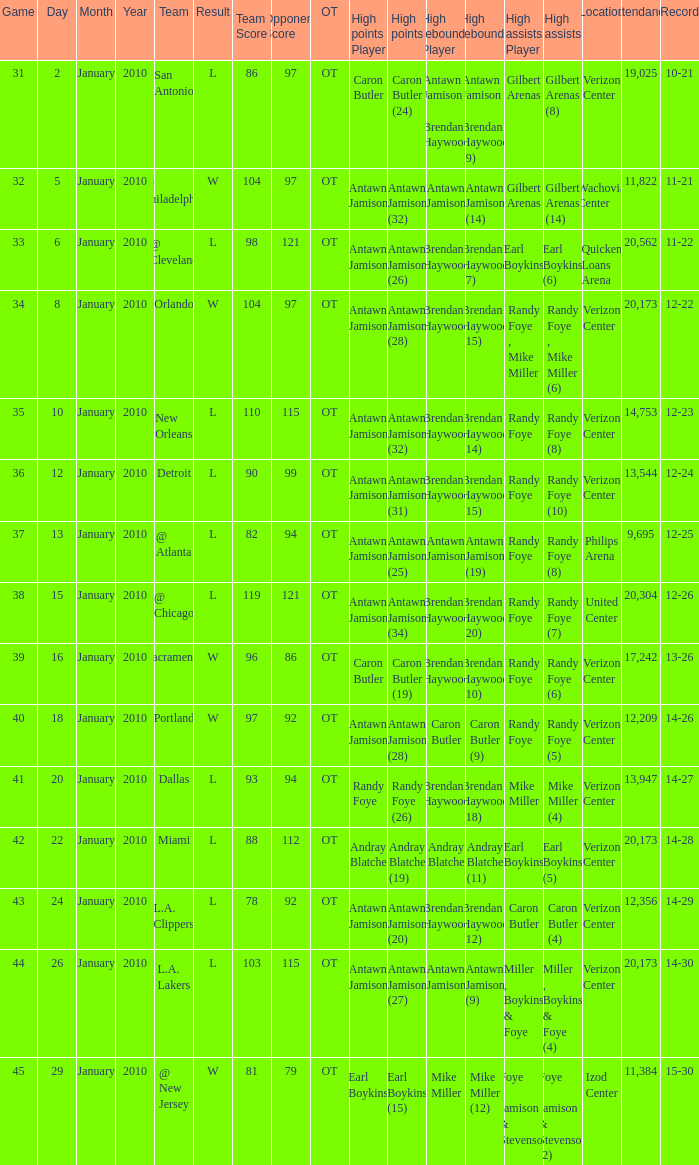Who had the highest points on January 2? Caron Butler (24). Would you mind parsing the complete table? {'header': ['Game', 'Day', 'Month', 'Year', 'Team', 'Result', 'Team Score', 'Opponent Score', 'OT', 'High points Player', 'High points', 'High rebounds Player', 'High rebounds', 'High assists Player', 'High assists', 'Location', 'Attendance', 'Record'], 'rows': [['31', '2', 'January', '2010', 'San Antonio', 'L', '86', '97', 'OT', 'Caron Butler', 'Caron Butler (24)', 'Antawn Jamison , Brendan Haywood', 'Antawn Jamison , Brendan Haywood (9)', 'Gilbert Arenas', 'Gilbert Arenas (8)', 'Verizon Center', '19,025', '10-21'], ['32', '5', 'January', '2010', '@ Philadelphia', 'W', '104', '97', 'OT', 'Antawn Jamison', 'Antawn Jamison (32)', 'Antawn Jamison', 'Antawn Jamison (14)', 'Gilbert Arenas', 'Gilbert Arenas (14)', 'Wachovia Center', '11,822', '11-21'], ['33', '6', 'January', '2010', '@ Cleveland', 'L', '98', '121', 'OT', 'Antawn Jamison', 'Antawn Jamison (26)', 'Brendan Haywood', 'Brendan Haywood (7)', 'Earl Boykins', 'Earl Boykins (6)', 'Quicken Loans Arena', '20,562', '11-22'], ['34', '8', 'January', '2010', 'Orlando', 'W', '104', '97', 'OT', 'Antawn Jamison', 'Antawn Jamison (28)', 'Brendan Haywood', 'Brendan Haywood (15)', 'Randy Foye , Mike Miller', 'Randy Foye , Mike Miller (6)', 'Verizon Center', '20,173', '12-22'], ['35', '10', 'January', '2010', 'New Orleans', 'L', '110', '115', 'OT', 'Antawn Jamison', 'Antawn Jamison (32)', 'Brendan Haywood', 'Brendan Haywood (14)', 'Randy Foye', 'Randy Foye (8)', 'Verizon Center', '14,753', '12-23'], ['36', '12', 'January', '2010', 'Detroit', 'L', '90', '99', 'OT', 'Antawn Jamison', 'Antawn Jamison (31)', 'Brendan Haywood', 'Brendan Haywood (15)', 'Randy Foye', 'Randy Foye (10)', 'Verizon Center', '13,544', '12-24'], ['37', '13', 'January', '2010', '@ Atlanta', 'L', '82', '94', 'OT', 'Antawn Jamison', 'Antawn Jamison (25)', 'Antawn Jamison', 'Antawn Jamison (19)', 'Randy Foye', 'Randy Foye (8)', 'Philips Arena', '9,695', '12-25'], ['38', '15', 'January', '2010', '@ Chicago', 'L', '119', '121', 'OT', 'Antawn Jamison', 'Antawn Jamison (34)', 'Brendan Haywood', 'Brendan Haywood (20)', 'Randy Foye', 'Randy Foye (7)', 'United Center', '20,304', '12-26'], ['39', '16', 'January', '2010', 'Sacramento', 'W', '96', '86', 'OT', 'Caron Butler', 'Caron Butler (19)', 'Brendan Haywood', 'Brendan Haywood (10)', 'Randy Foye', 'Randy Foye (6)', 'Verizon Center', '17,242', '13-26'], ['40', '18', 'January', '2010', 'Portland', 'W', '97', '92', 'OT', 'Antawn Jamison', 'Antawn Jamison (28)', 'Caron Butler', 'Caron Butler (9)', 'Randy Foye', 'Randy Foye (5)', 'Verizon Center', '12,209', '14-26'], ['41', '20', 'January', '2010', 'Dallas', 'L', '93', '94', 'OT', 'Randy Foye', 'Randy Foye (26)', 'Brendan Haywood', 'Brendan Haywood (18)', 'Mike Miller', 'Mike Miller (4)', 'Verizon Center', '13,947', '14-27'], ['42', '22', 'January', '2010', 'Miami', 'L', '88', '112', 'OT', 'Andray Blatche', 'Andray Blatche (19)', 'Andray Blatche', 'Andray Blatche (11)', 'Earl Boykins', 'Earl Boykins (5)', 'Verizon Center', '20,173', '14-28'], ['43', '24', 'January', '2010', 'L.A. Clippers', 'L', '78', '92', 'OT', 'Antawn Jamison', 'Antawn Jamison (20)', 'Brendan Haywood', 'Brendan Haywood (12)', 'Caron Butler', 'Caron Butler (4)', 'Verizon Center', '12,356', '14-29'], ['44', '26', 'January', '2010', 'L.A. Lakers', 'L', '103', '115', 'OT', 'Antawn Jamison', 'Antawn Jamison (27)', 'Antawn Jamison', 'Antawn Jamison (9)', 'Miller , Boykins & Foye', 'Miller , Boykins & Foye (4)', 'Verizon Center', '20,173', '14-30'], ['45', '29', 'January', '2010', '@ New Jersey', 'W', '81', '79', 'OT', 'Earl Boykins', 'Earl Boykins (15)', 'Mike Miller', 'Mike Miller (12)', 'Foye , Jamison & Stevenson', 'Foye , Jamison & Stevenson (2)', 'Izod Center', '11,384', '15-30']]} 